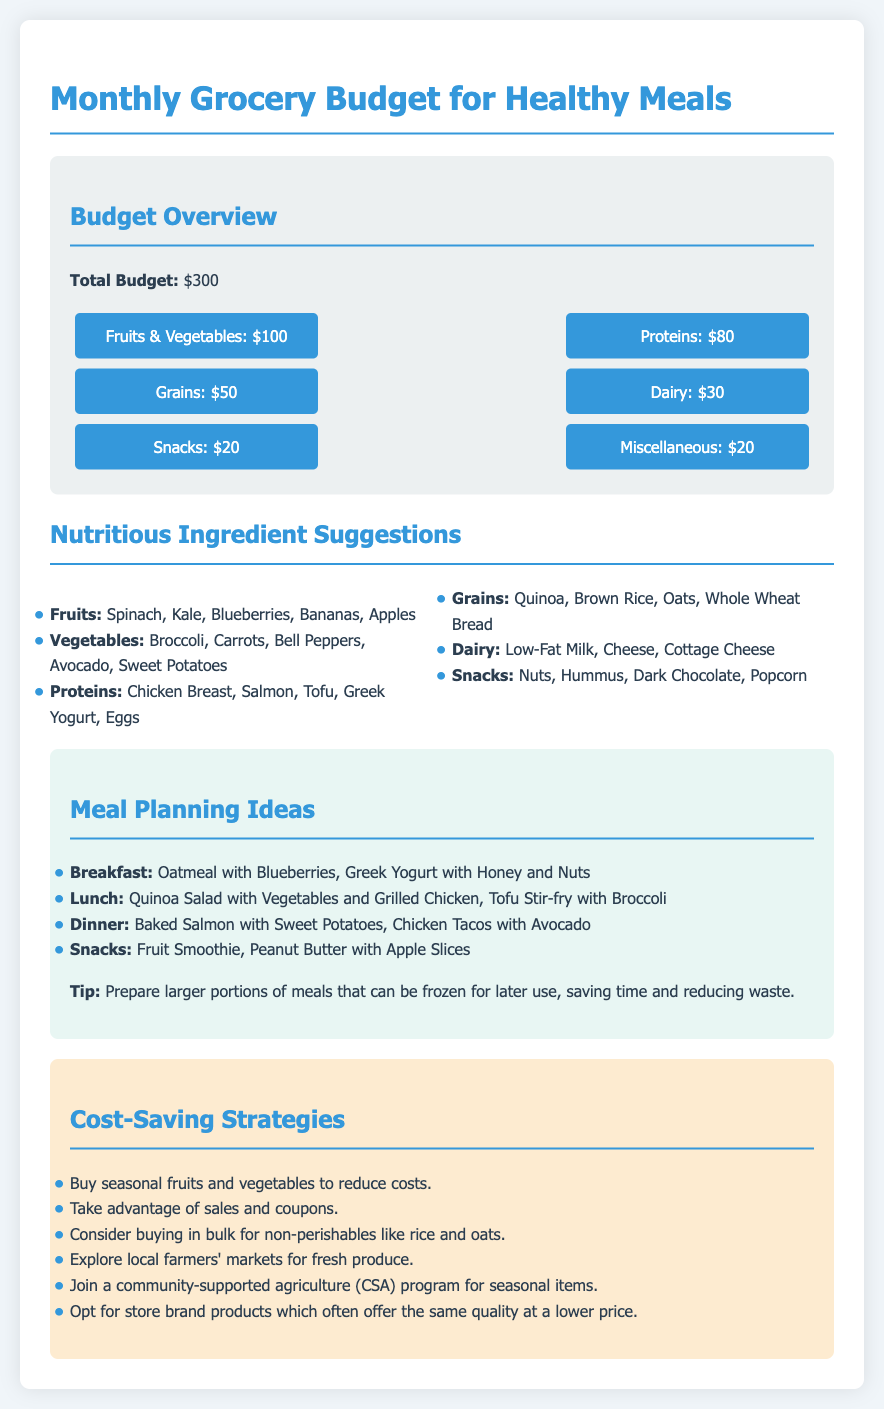What is the total monthly grocery budget? The total monthly grocery budget is explicitly stated as $300.
Answer: $300 How much is allocated for fruits and vegetables? The document specifies that $100 is allocated for fruits and vegetables under the budget overview.
Answer: $100 What are two protein sources recommended? The document lists Chicken Breast and Salmon as two sources of protein in the nutritious ingredient suggestions.
Answer: Chicken Breast, Salmon What is one breakfast idea mentioned? The document suggests Oatmeal with Blueberries as one option for breakfast in the meal planning ideas.
Answer: Oatmeal with Blueberries How much is the budget for snacks? The budget overview section indicates that $20 is allocated specifically for snacks.
Answer: $20 What is a cost-saving strategy listed? The document lists "Buy seasonal fruits and vegetables to reduce costs" as one cost-saving strategy.
Answer: Buy seasonal fruits and vegetables What percentage of the total budget is allocated for dairy? $30 is allocated for dairy, which is 10% of the total $300 budget (30/300)*100.
Answer: 10% What is one meal idea for lunch? The document mentions "Quinoa Salad with Vegetables and Grilled Chicken" as a lunch meal idea.
Answer: Quinoa Salad with Vegetables and Grilled Chicken What miscellaneous expenses are included in the budget? The budget overview shows $20 allocated to miscellaneous expenses.
Answer: $20 